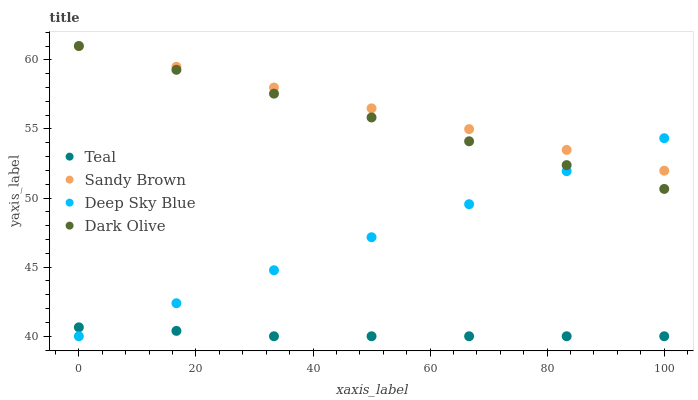Does Teal have the minimum area under the curve?
Answer yes or no. Yes. Does Sandy Brown have the maximum area under the curve?
Answer yes or no. Yes. Does Deep Sky Blue have the minimum area under the curve?
Answer yes or no. No. Does Deep Sky Blue have the maximum area under the curve?
Answer yes or no. No. Is Deep Sky Blue the smoothest?
Answer yes or no. Yes. Is Teal the roughest?
Answer yes or no. Yes. Is Sandy Brown the smoothest?
Answer yes or no. No. Is Sandy Brown the roughest?
Answer yes or no. No. Does Deep Sky Blue have the lowest value?
Answer yes or no. Yes. Does Sandy Brown have the lowest value?
Answer yes or no. No. Does Sandy Brown have the highest value?
Answer yes or no. Yes. Does Deep Sky Blue have the highest value?
Answer yes or no. No. Is Teal less than Sandy Brown?
Answer yes or no. Yes. Is Sandy Brown greater than Teal?
Answer yes or no. Yes. Does Teal intersect Deep Sky Blue?
Answer yes or no. Yes. Is Teal less than Deep Sky Blue?
Answer yes or no. No. Is Teal greater than Deep Sky Blue?
Answer yes or no. No. Does Teal intersect Sandy Brown?
Answer yes or no. No. 